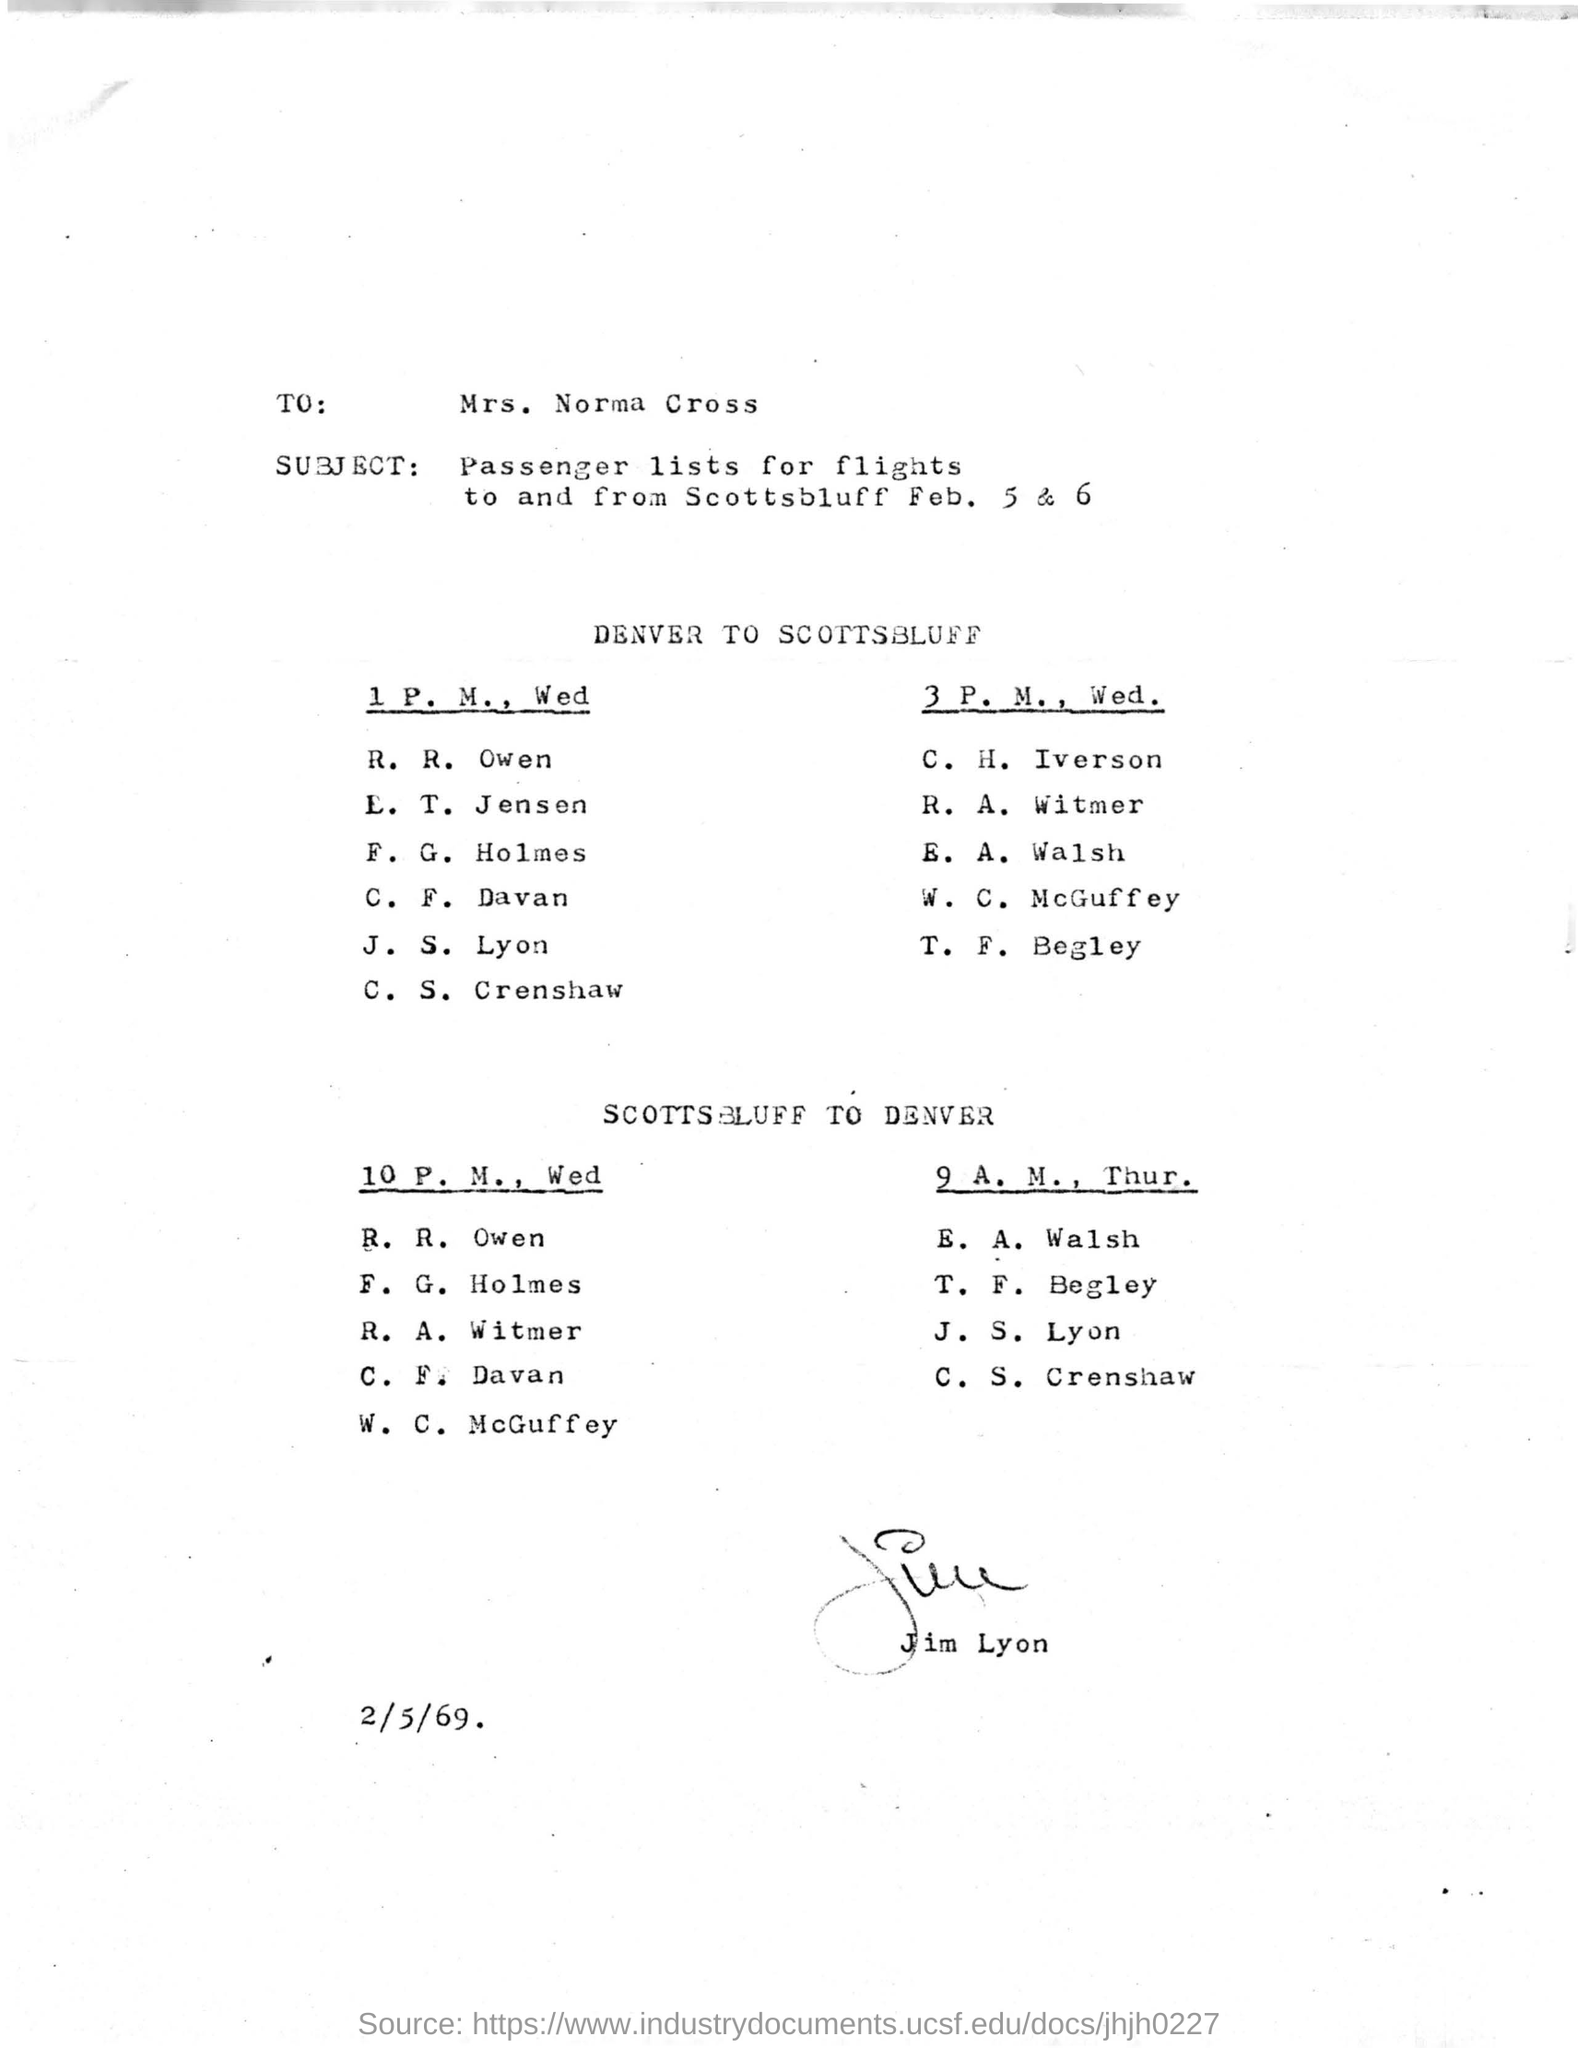To whom the document is addressed to?
Your answer should be compact. Mrs. Norma Cross. What is the subject mentioned in this document?
Keep it short and to the point. Passenger lists for flights to and from Scottsbluff Feb. 5 & 6. Who has signed this document?
Offer a terse response. Jim Lyon. What is the date mentioned in this document?
Offer a terse response. 2/5/69. 